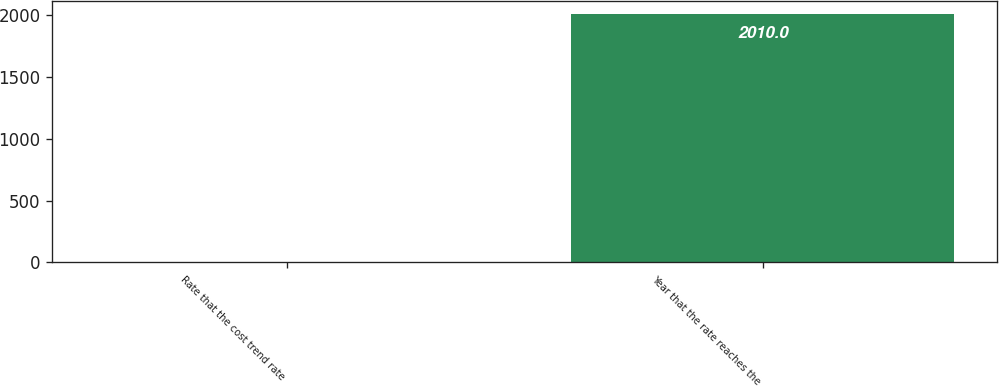Convert chart to OTSL. <chart><loc_0><loc_0><loc_500><loc_500><bar_chart><fcel>Rate that the cost trend rate<fcel>Year that the rate reaches the<nl><fcel>5<fcel>2010<nl></chart> 